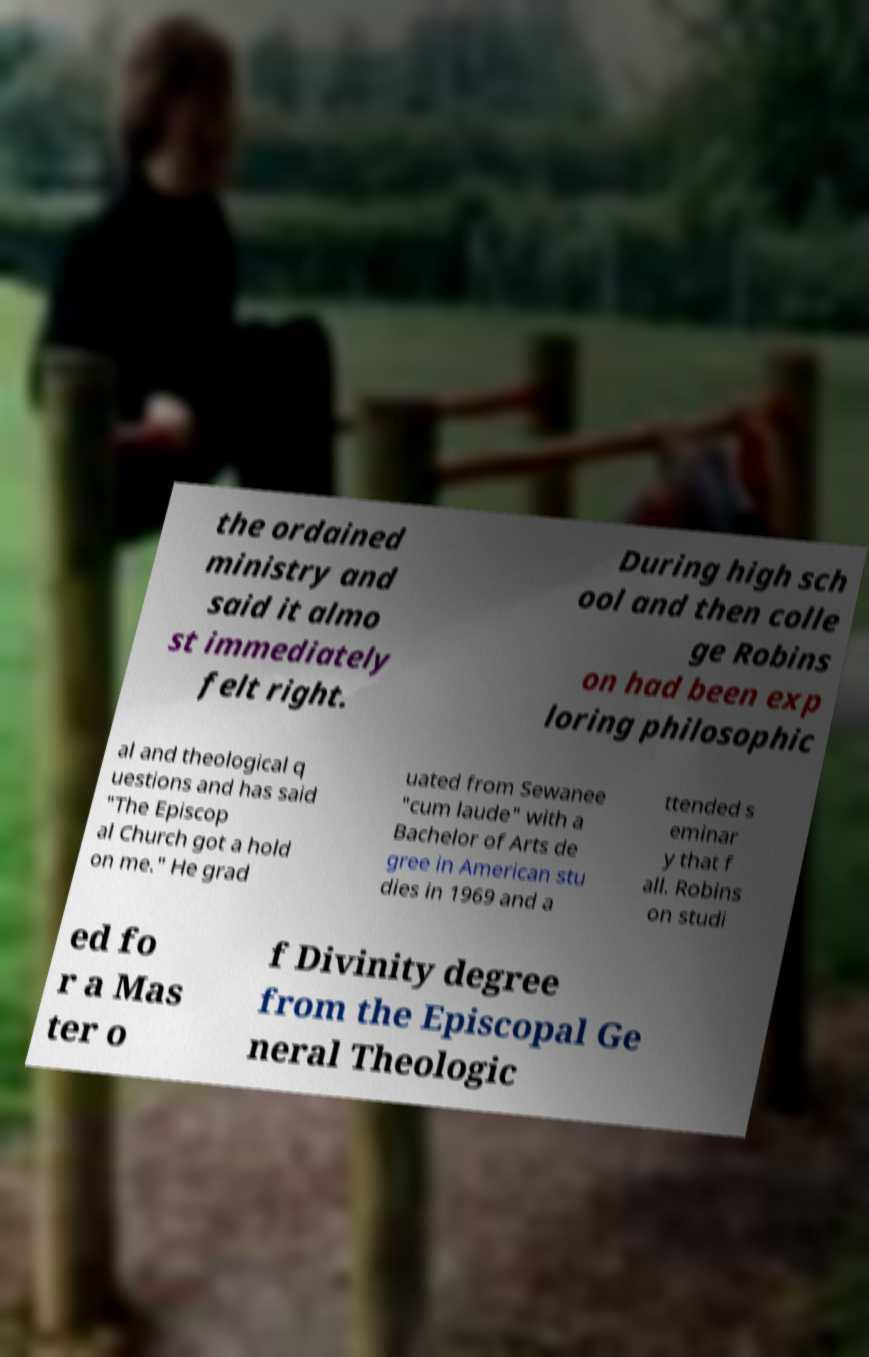Could you extract and type out the text from this image? the ordained ministry and said it almo st immediately felt right. During high sch ool and then colle ge Robins on had been exp loring philosophic al and theological q uestions and has said "The Episcop al Church got a hold on me." He grad uated from Sewanee "cum laude" with a Bachelor of Arts de gree in American stu dies in 1969 and a ttended s eminar y that f all. Robins on studi ed fo r a Mas ter o f Divinity degree from the Episcopal Ge neral Theologic 